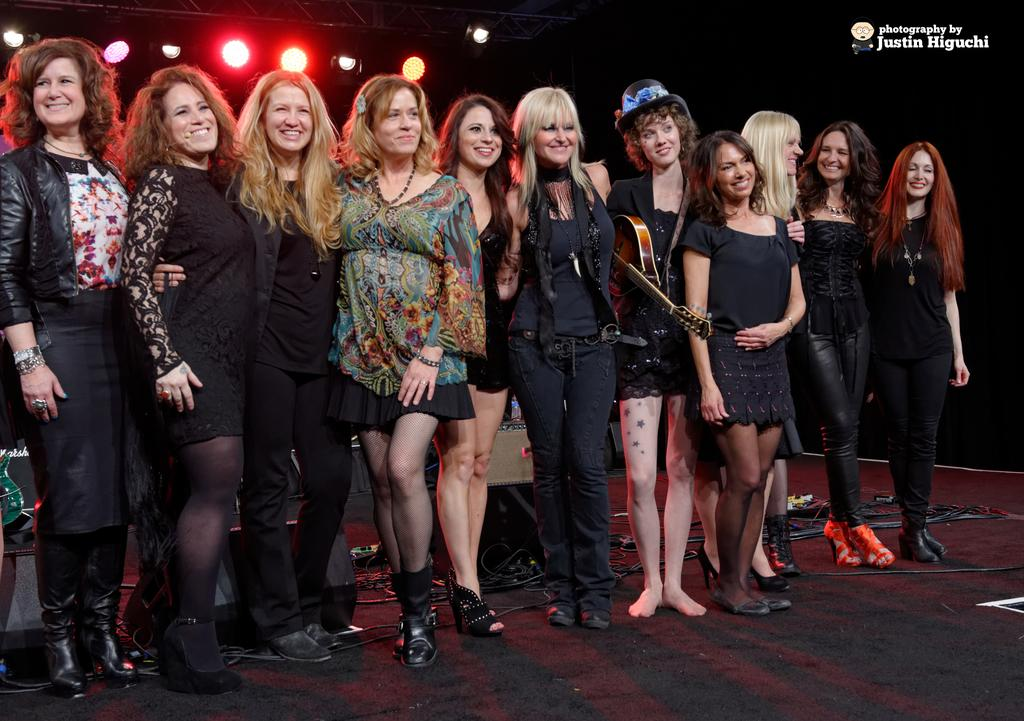How many people are in the image? There is a group of people in the image. What can be observed about the clothing of the people in the image? The people are wearing different dress. What activity might the person holding a musical instrument be engaged in? The person holding a musical instrument might be playing music. What can be seen in the background of the image? There are lights visible in the background, and the background is in black color. What type of letters can be seen on the cup in the image? There is no cup present in the image, so no letters can be observed on a cup. Can you describe the color of the orange in the image? There is no orange present in the image. 